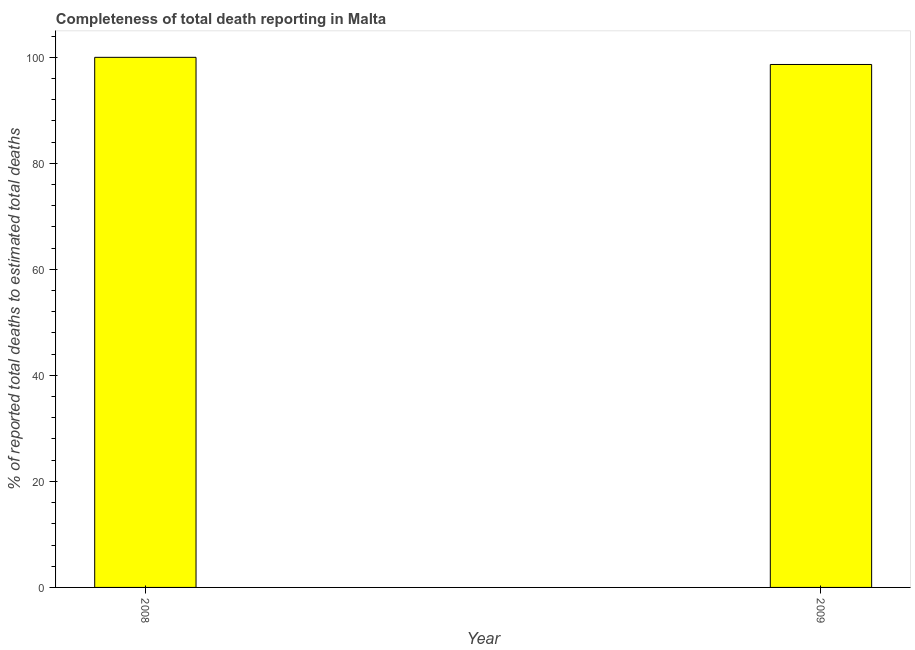Does the graph contain any zero values?
Make the answer very short. No. Does the graph contain grids?
Provide a short and direct response. No. What is the title of the graph?
Your answer should be very brief. Completeness of total death reporting in Malta. What is the label or title of the Y-axis?
Keep it short and to the point. % of reported total deaths to estimated total deaths. What is the completeness of total death reports in 2009?
Offer a terse response. 98.65. Across all years, what is the minimum completeness of total death reports?
Ensure brevity in your answer.  98.65. In which year was the completeness of total death reports maximum?
Your answer should be very brief. 2008. In which year was the completeness of total death reports minimum?
Your answer should be very brief. 2009. What is the sum of the completeness of total death reports?
Your answer should be very brief. 198.65. What is the difference between the completeness of total death reports in 2008 and 2009?
Give a very brief answer. 1.35. What is the average completeness of total death reports per year?
Your answer should be compact. 99.33. What is the median completeness of total death reports?
Offer a terse response. 99.33. In how many years, is the completeness of total death reports greater than 68 %?
Give a very brief answer. 2. Do a majority of the years between 2008 and 2009 (inclusive) have completeness of total death reports greater than 4 %?
Your response must be concise. Yes. What is the ratio of the completeness of total death reports in 2008 to that in 2009?
Give a very brief answer. 1.01. In how many years, is the completeness of total death reports greater than the average completeness of total death reports taken over all years?
Keep it short and to the point. 1. How many bars are there?
Your answer should be compact. 2. What is the difference between two consecutive major ticks on the Y-axis?
Offer a very short reply. 20. What is the % of reported total deaths to estimated total deaths of 2009?
Provide a short and direct response. 98.65. What is the difference between the % of reported total deaths to estimated total deaths in 2008 and 2009?
Keep it short and to the point. 1.35. What is the ratio of the % of reported total deaths to estimated total deaths in 2008 to that in 2009?
Your answer should be very brief. 1.01. 